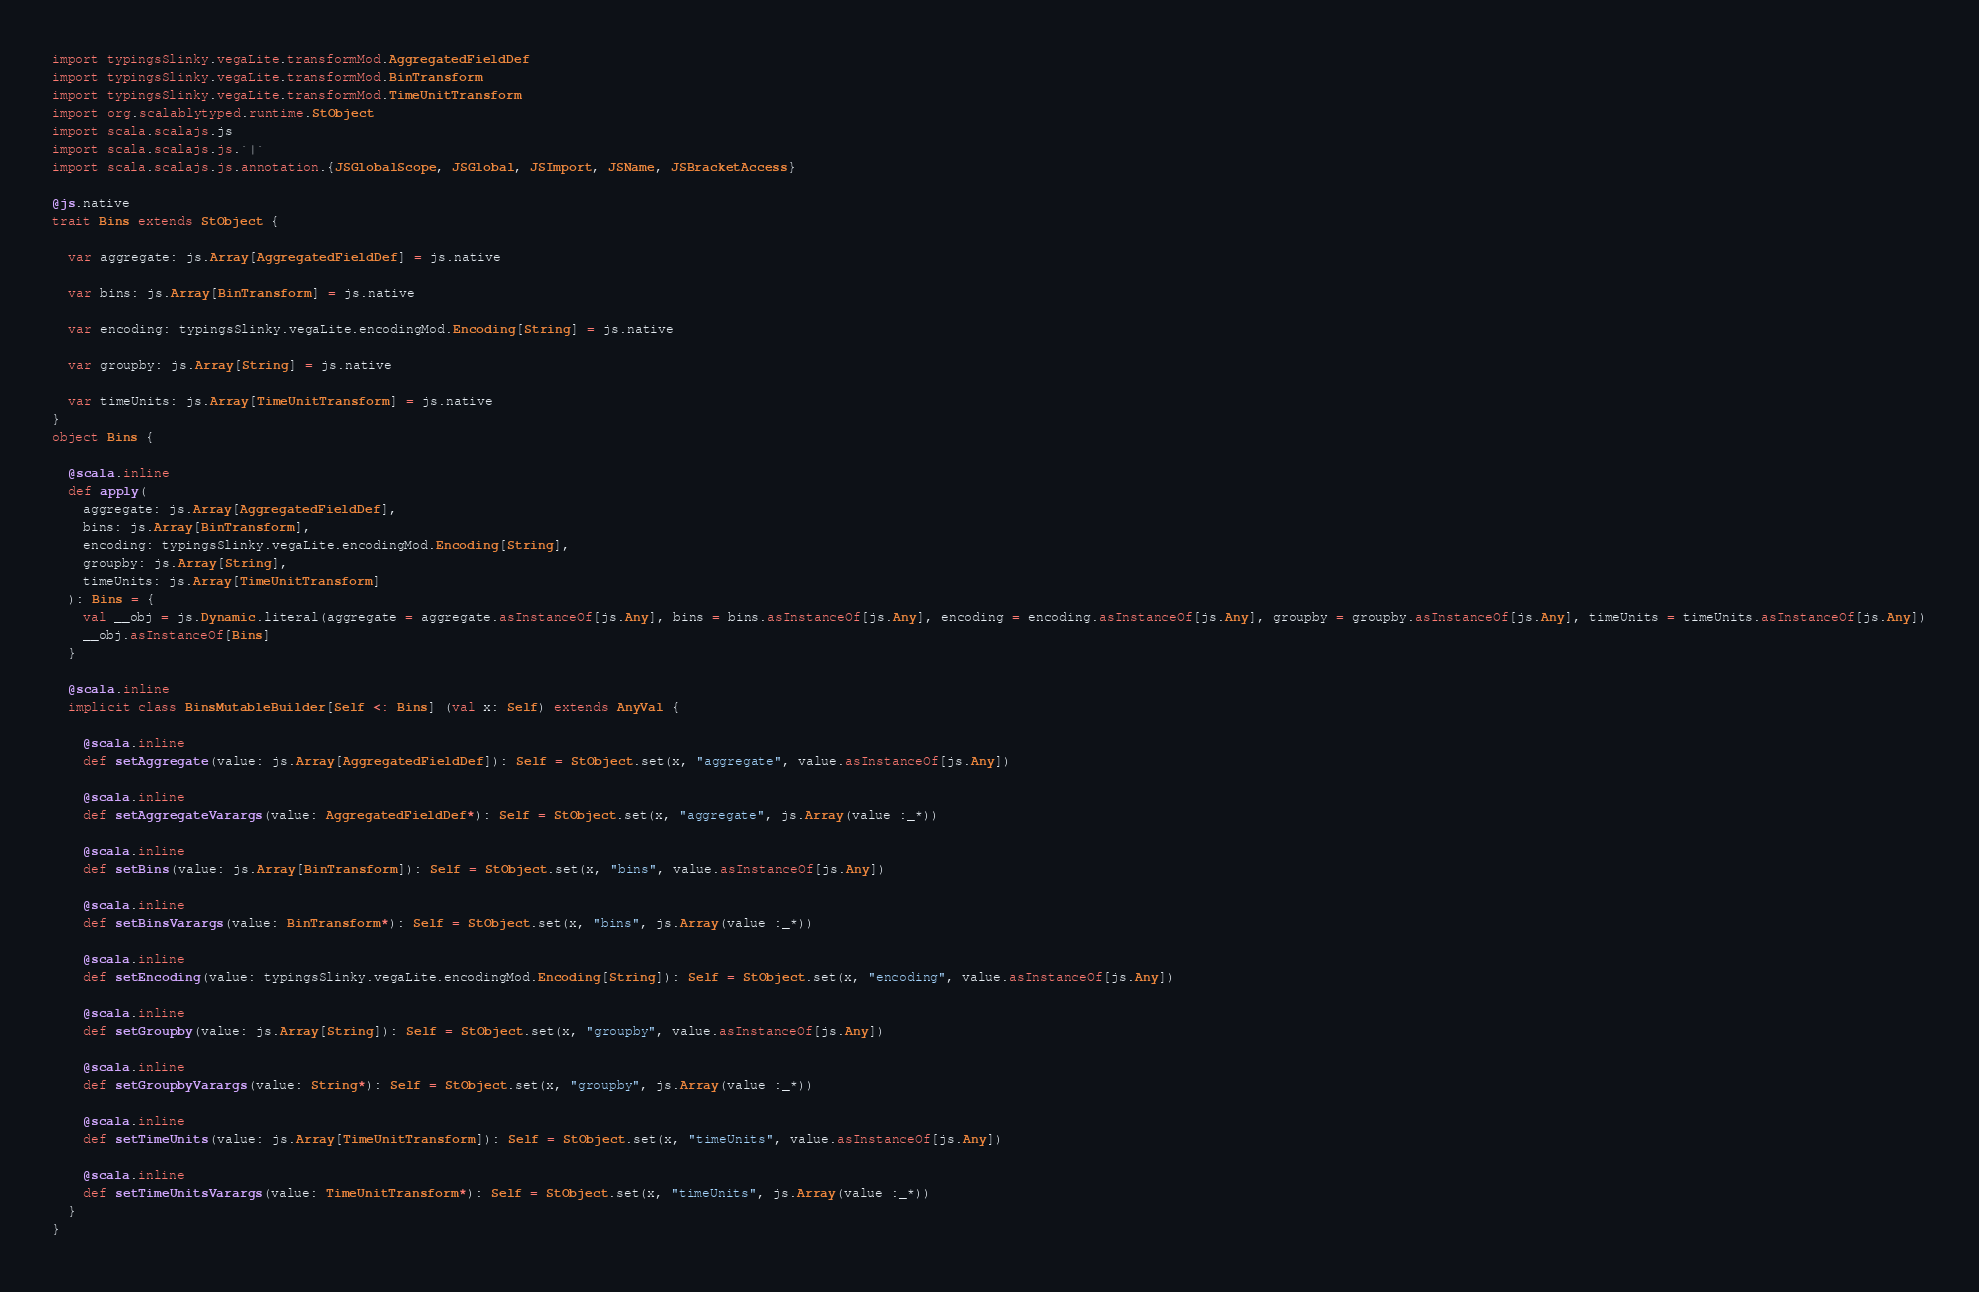<code> <loc_0><loc_0><loc_500><loc_500><_Scala_>import typingsSlinky.vegaLite.transformMod.AggregatedFieldDef
import typingsSlinky.vegaLite.transformMod.BinTransform
import typingsSlinky.vegaLite.transformMod.TimeUnitTransform
import org.scalablytyped.runtime.StObject
import scala.scalajs.js
import scala.scalajs.js.`|`
import scala.scalajs.js.annotation.{JSGlobalScope, JSGlobal, JSImport, JSName, JSBracketAccess}

@js.native
trait Bins extends StObject {
  
  var aggregate: js.Array[AggregatedFieldDef] = js.native
  
  var bins: js.Array[BinTransform] = js.native
  
  var encoding: typingsSlinky.vegaLite.encodingMod.Encoding[String] = js.native
  
  var groupby: js.Array[String] = js.native
  
  var timeUnits: js.Array[TimeUnitTransform] = js.native
}
object Bins {
  
  @scala.inline
  def apply(
    aggregate: js.Array[AggregatedFieldDef],
    bins: js.Array[BinTransform],
    encoding: typingsSlinky.vegaLite.encodingMod.Encoding[String],
    groupby: js.Array[String],
    timeUnits: js.Array[TimeUnitTransform]
  ): Bins = {
    val __obj = js.Dynamic.literal(aggregate = aggregate.asInstanceOf[js.Any], bins = bins.asInstanceOf[js.Any], encoding = encoding.asInstanceOf[js.Any], groupby = groupby.asInstanceOf[js.Any], timeUnits = timeUnits.asInstanceOf[js.Any])
    __obj.asInstanceOf[Bins]
  }
  
  @scala.inline
  implicit class BinsMutableBuilder[Self <: Bins] (val x: Self) extends AnyVal {
    
    @scala.inline
    def setAggregate(value: js.Array[AggregatedFieldDef]): Self = StObject.set(x, "aggregate", value.asInstanceOf[js.Any])
    
    @scala.inline
    def setAggregateVarargs(value: AggregatedFieldDef*): Self = StObject.set(x, "aggregate", js.Array(value :_*))
    
    @scala.inline
    def setBins(value: js.Array[BinTransform]): Self = StObject.set(x, "bins", value.asInstanceOf[js.Any])
    
    @scala.inline
    def setBinsVarargs(value: BinTransform*): Self = StObject.set(x, "bins", js.Array(value :_*))
    
    @scala.inline
    def setEncoding(value: typingsSlinky.vegaLite.encodingMod.Encoding[String]): Self = StObject.set(x, "encoding", value.asInstanceOf[js.Any])
    
    @scala.inline
    def setGroupby(value: js.Array[String]): Self = StObject.set(x, "groupby", value.asInstanceOf[js.Any])
    
    @scala.inline
    def setGroupbyVarargs(value: String*): Self = StObject.set(x, "groupby", js.Array(value :_*))
    
    @scala.inline
    def setTimeUnits(value: js.Array[TimeUnitTransform]): Self = StObject.set(x, "timeUnits", value.asInstanceOf[js.Any])
    
    @scala.inline
    def setTimeUnitsVarargs(value: TimeUnitTransform*): Self = StObject.set(x, "timeUnits", js.Array(value :_*))
  }
}
</code> 